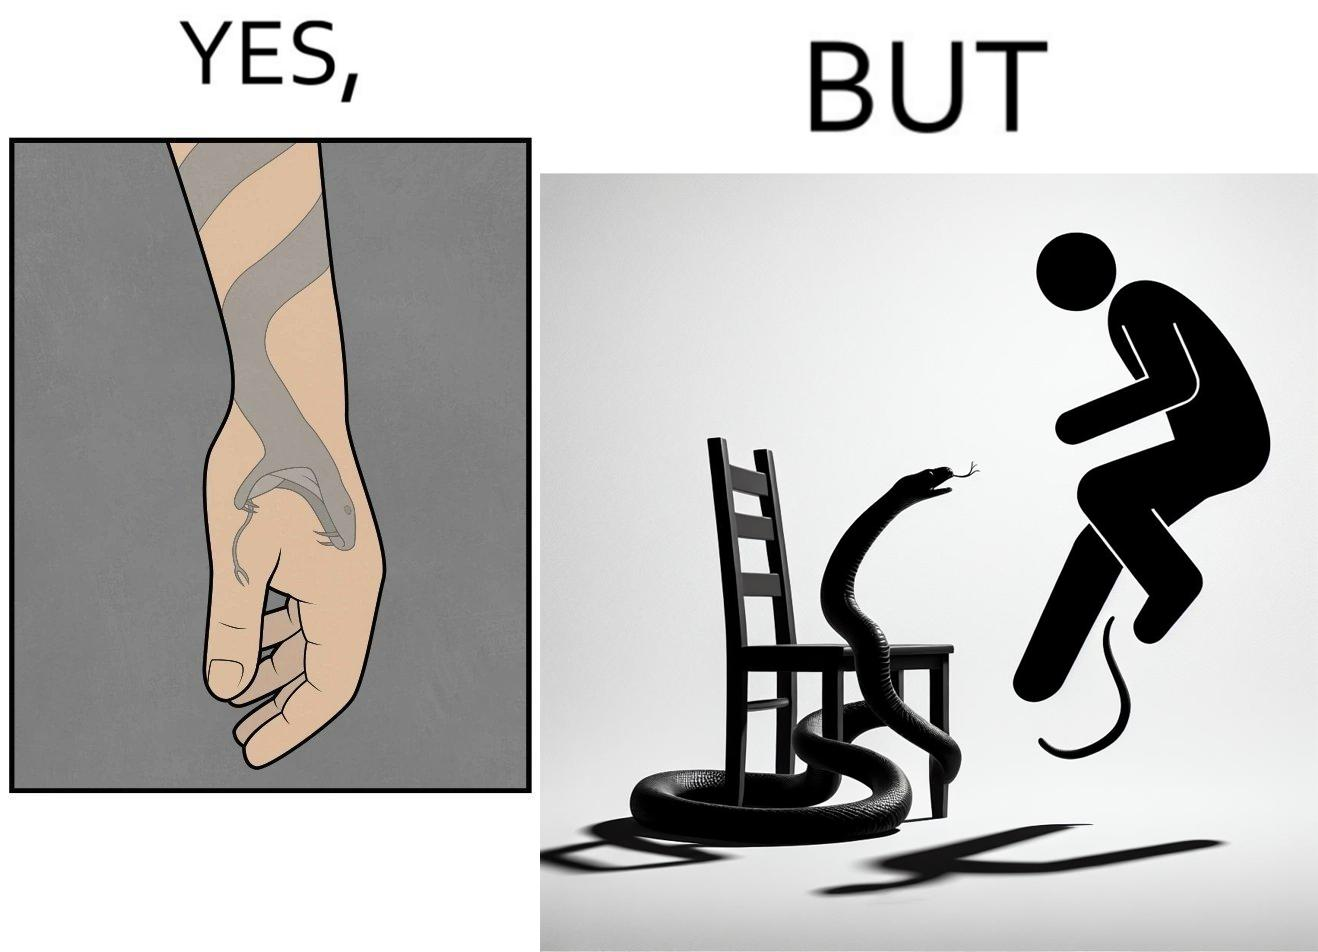Describe the satirical element in this image. The image is ironic, because in the first image the tattoo of a snake on someone's hand may give us a hint about how powerful or brave the person can be who is having this tattoo but in the second image the person with same tattoo is seen frightened due to a snake in his house 